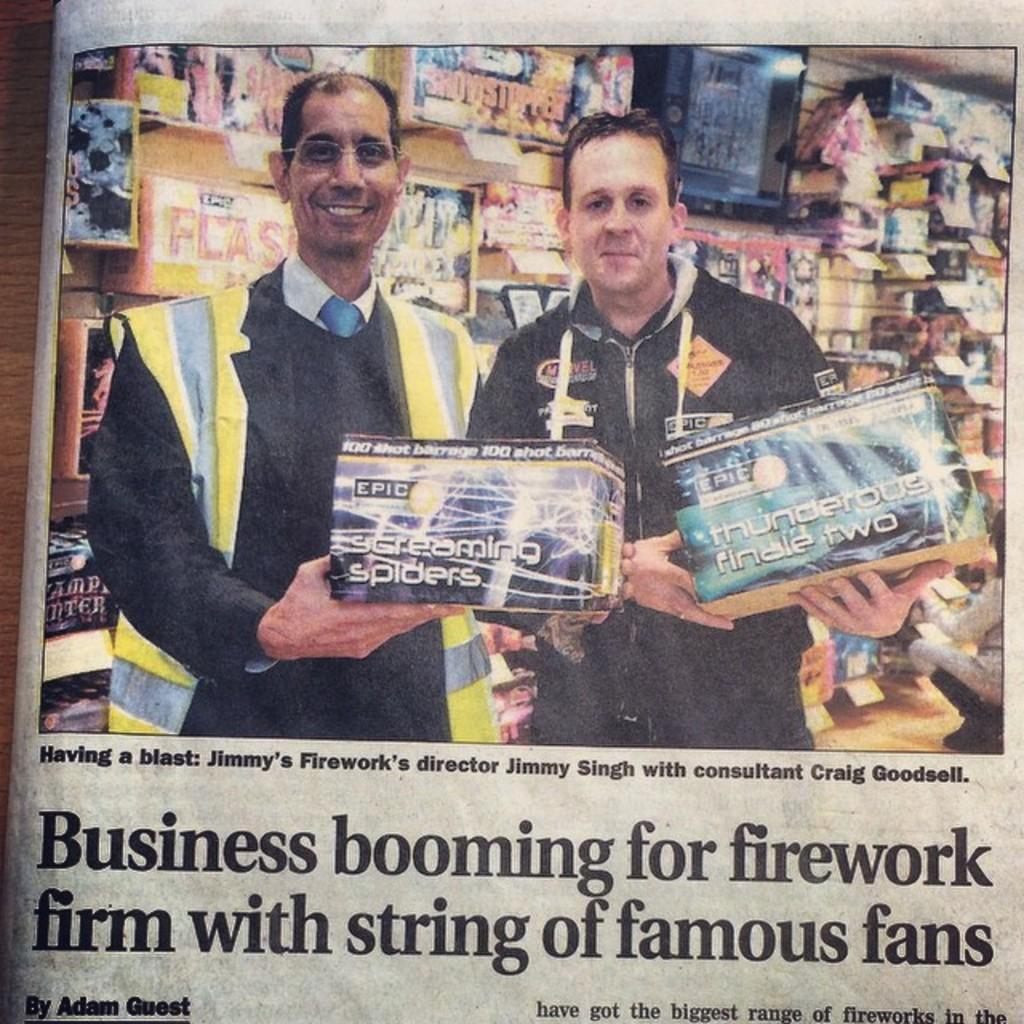Describe this image in one or two sentences. This looks like a newspaper. I can see the picture of the woman standing and holding an object in their hands. I think these are the toys. I can see the letters in the newspaper. 